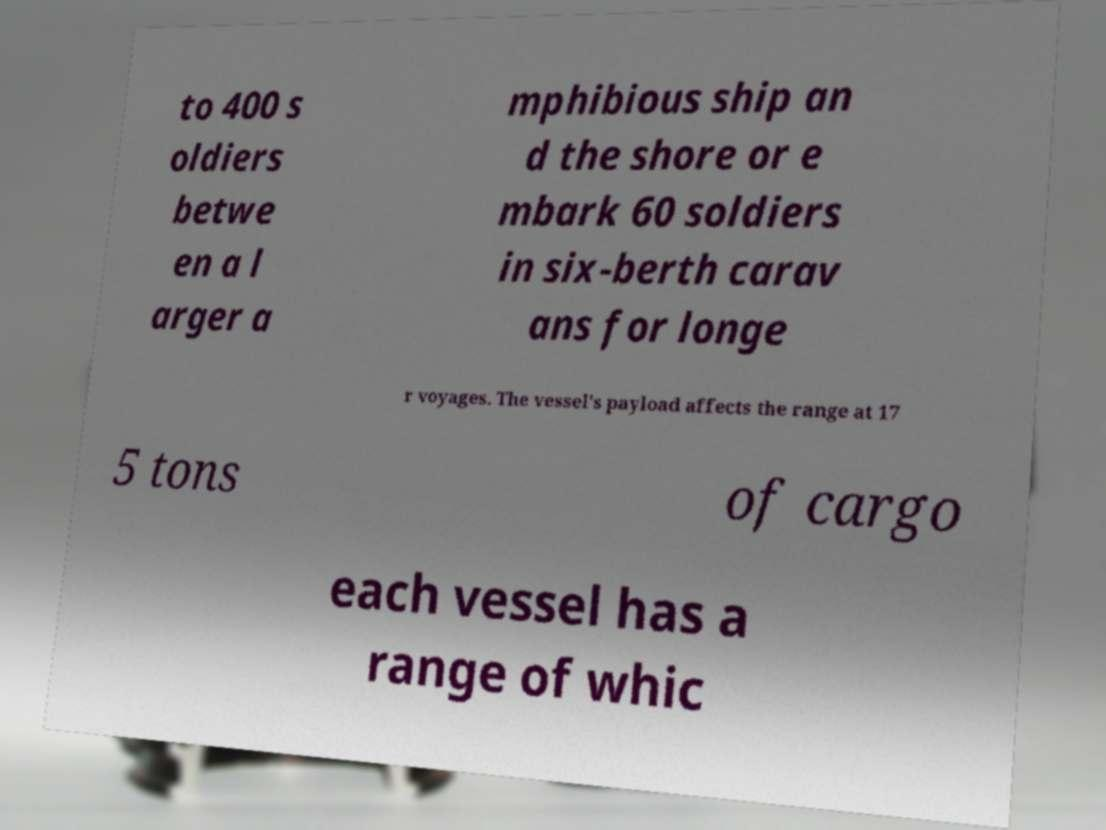Could you extract and type out the text from this image? to 400 s oldiers betwe en a l arger a mphibious ship an d the shore or e mbark 60 soldiers in six-berth carav ans for longe r voyages. The vessel's payload affects the range at 17 5 tons of cargo each vessel has a range of whic 